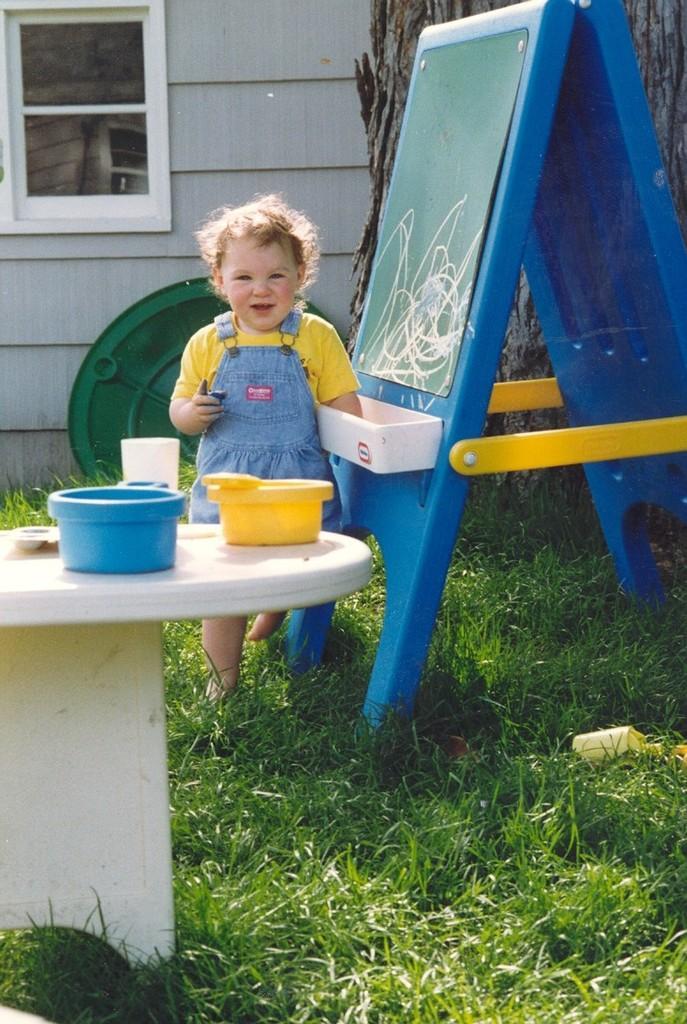In one or two sentences, can you explain what this image depicts? This is the picture taken in the outdoor. A baby is playing in a grass. In front of the baby there is a table on the table there are bowls and behind the baby is a window glass. 